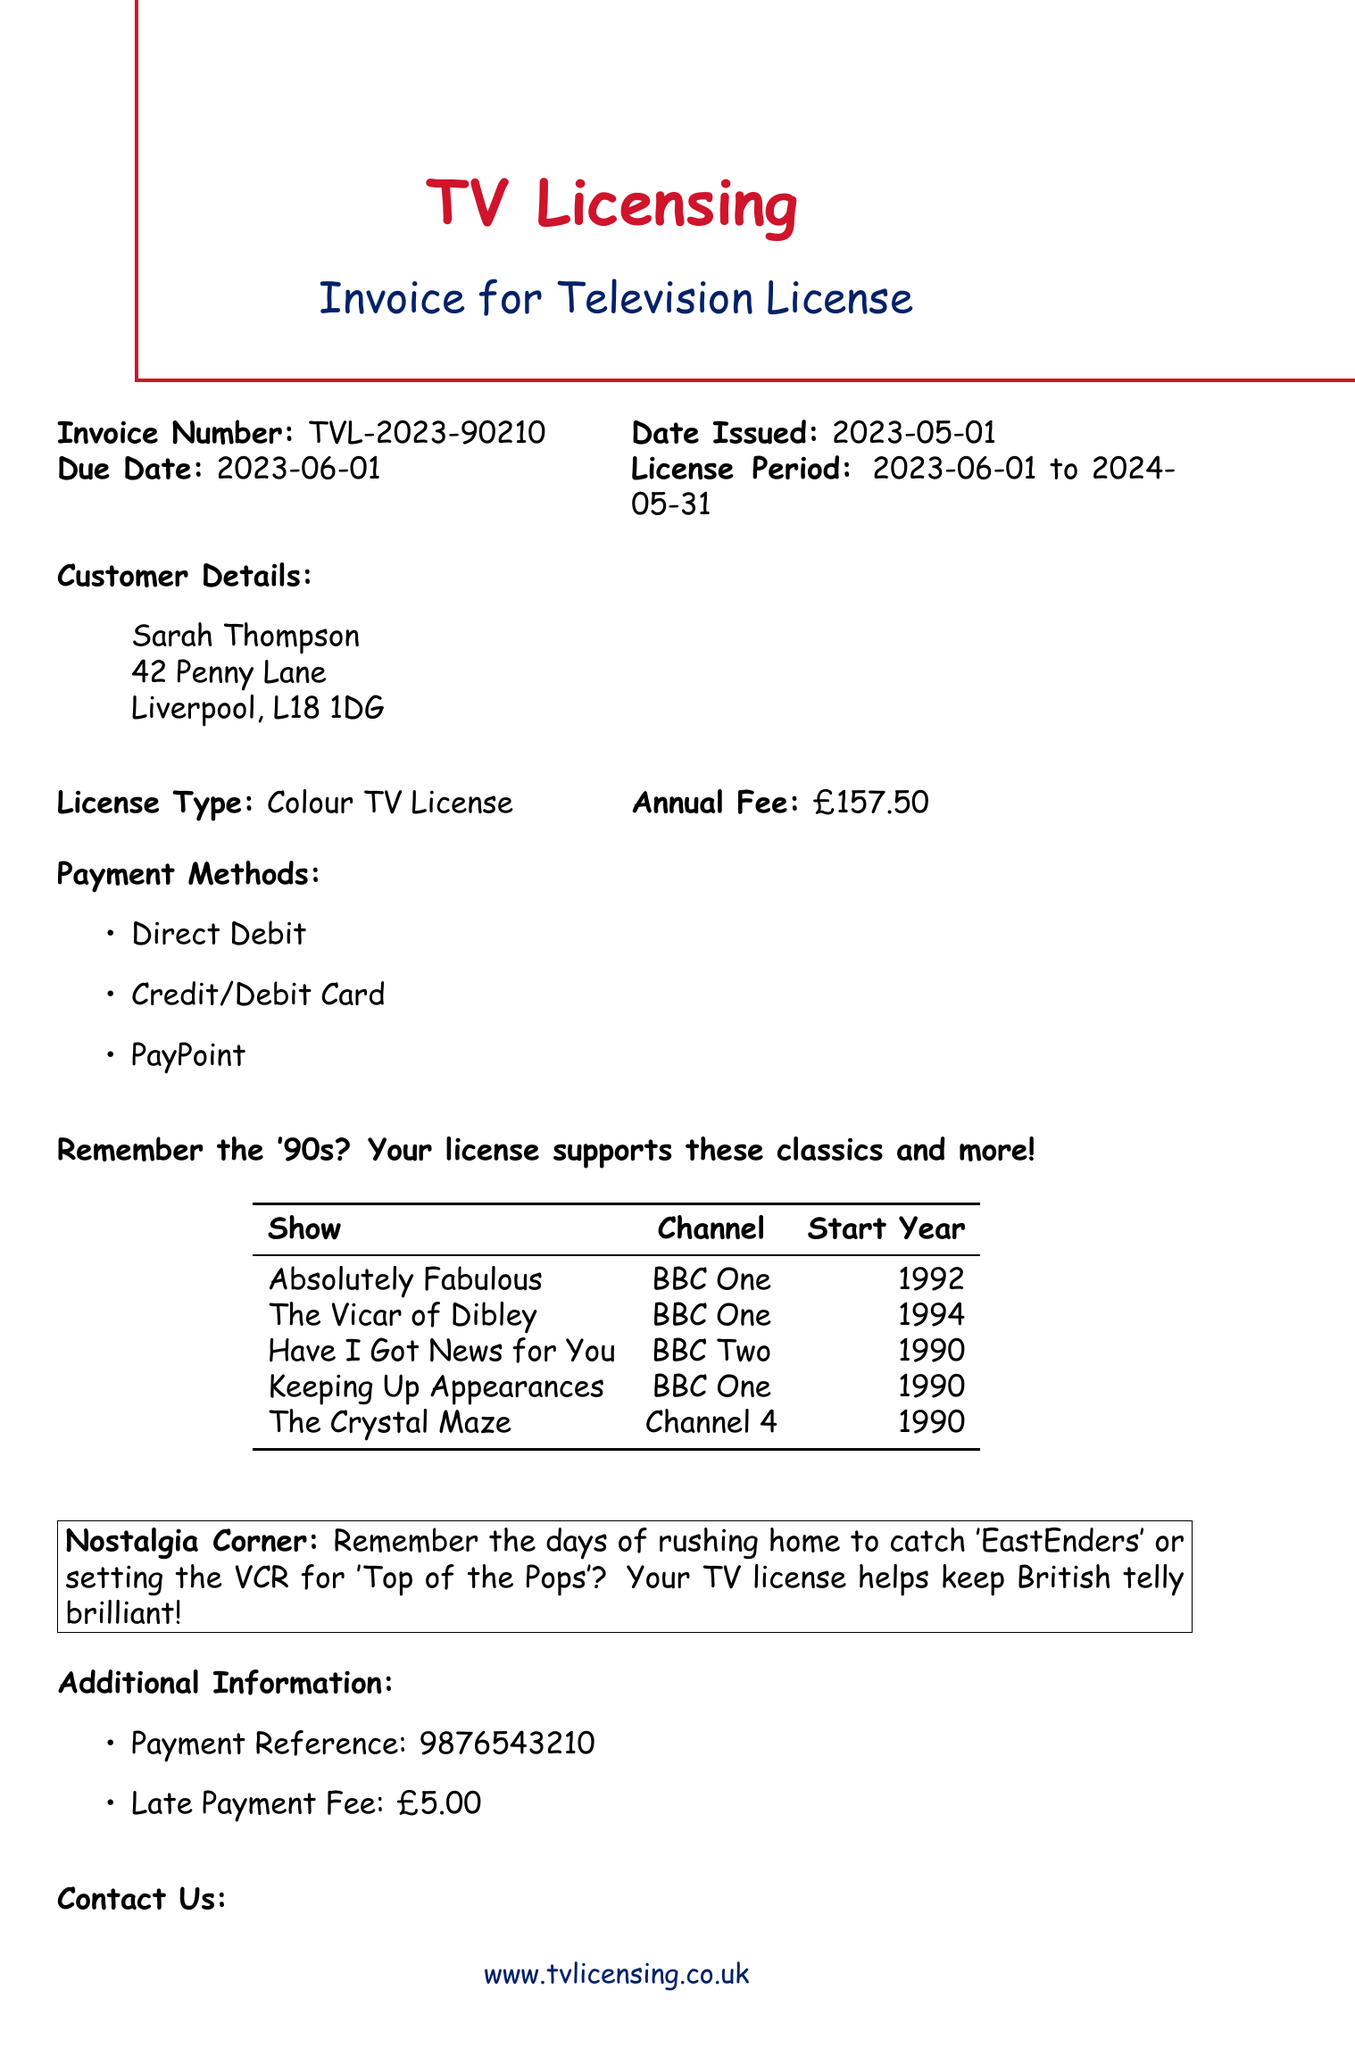What is the invoice number? The invoice number is specifically stated in the document for reference and tracking.
Answer: TVL-2023-90210 What is the annual fee for the TV license? The document clearly states the annual fee associated with the TV license.
Answer: £157.50 What is the due date for the payment? The due date helps understand when the payment must be made according to the invoice's details.
Answer: 2023-06-01 Who is the customer named on the invoice? The customer's name is listed in the customer details section, indicating who the invoice is issued to.
Answer: Sarah Thompson Which channel broadcasts "Absolutely Fabulous"? This popular show and its broadcasting channel are listed together in the document.
Answer: BBC One What payment methods are available? The document lists the methods for making the payment; understanding these helps with payment options.
Answer: Direct Debit, Credit/Debit Card, PayPoint What is the late payment fee? The document mentions the fee applicable if payment is not made on time.
Answer: £5.00 What license type is this invoice for? The type of license is clearly specified, indicating what the payment supports.
Answer: Colour TV License What does the reminder message suggest about British television? This message reflects a nostalgic sentiment and highlights the importance of the TV license.
Answer: Helps keep British telly brilliant! 